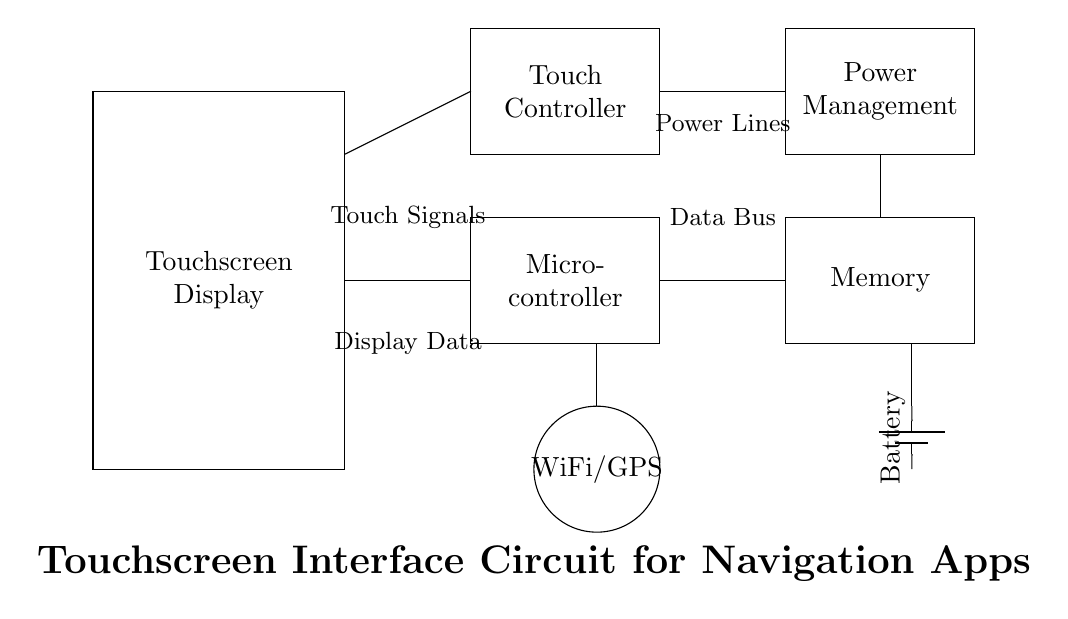What does the rectangle on the left represent? The rectangle on the left labeled "Touchscreen Display" indicates the part of the mobile device that users interact with to input commands and view information.
Answer: Touchscreen Display How many primary components are shown in this circuit? The circuit shows five primary components, which include the touchscreen display, micro-controller, touch controller, memory, and power management.
Answer: Five What type of signals do the connections between the touchscreen and the micro-controller represent? The connections (lines) between the touchscreen and micro-controller represent the transfer of touch signals, allowing the system to respond to user input.
Answer: Touch Signals Which component is responsible for managing power supply? The component labeled "Power Management" is responsible for handling the distribution and regulation of power to other components in the circuit.
Answer: Power Management What is the function of the WiFi/GPS component in this circuit? The WiFi/GPS component provides connectivity and location services, enabling the mobile device to access the internet and determine geographic positioning.
Answer: WiFi/GPS Which components are connected to the memory in the circuit? The memory is connected to both the micro-controller and power management, indicating it stores information and requires power to operate.
Answer: Micro-controller and Power Management Why is the touch controller necessary in this circuit? The touch controller processes signals from the touchscreen and translates them into commands for the micro-controller, allowing for responsive navigation within the app.
Answer: Touch Controller 